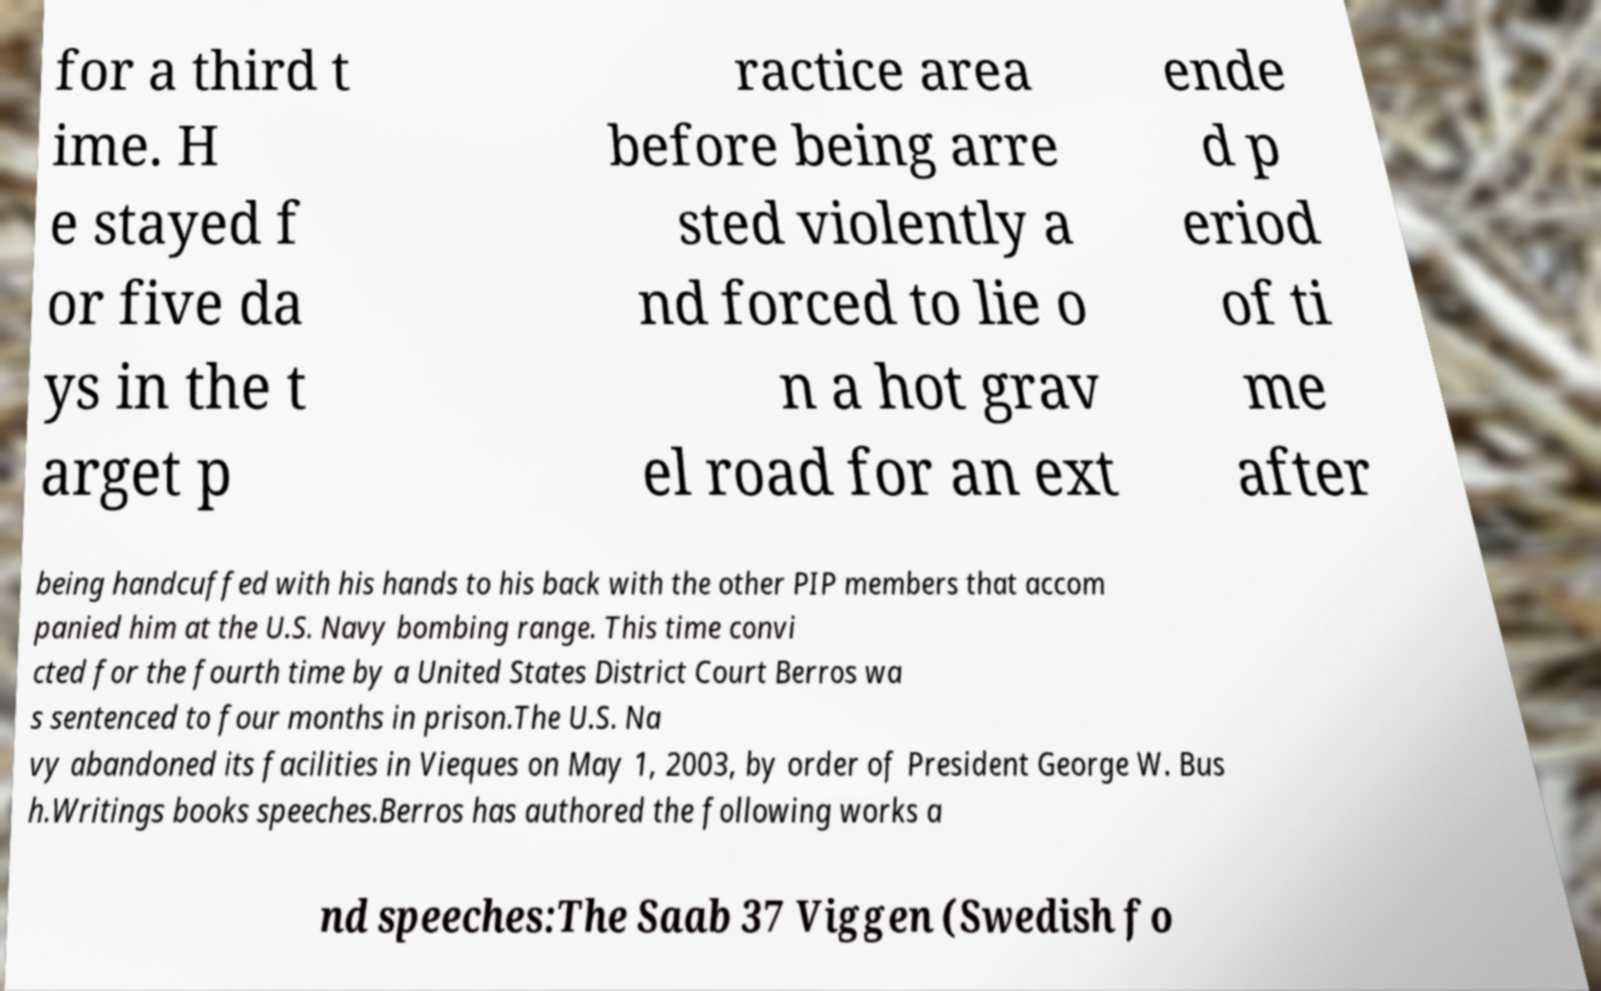Could you assist in decoding the text presented in this image and type it out clearly? for a third t ime. H e stayed f or five da ys in the t arget p ractice area before being arre sted violently a nd forced to lie o n a hot grav el road for an ext ende d p eriod of ti me after being handcuffed with his hands to his back with the other PIP members that accom panied him at the U.S. Navy bombing range. This time convi cted for the fourth time by a United States District Court Berros wa s sentenced to four months in prison.The U.S. Na vy abandoned its facilities in Vieques on May 1, 2003, by order of President George W. Bus h.Writings books speeches.Berros has authored the following works a nd speeches:The Saab 37 Viggen (Swedish fo 